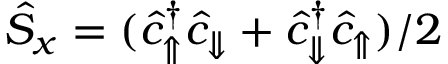Convert formula to latex. <formula><loc_0><loc_0><loc_500><loc_500>\hat { S } _ { x } = ( \hat { c } _ { \Uparrow } ^ { \dagger } \hat { c } _ { \Downarrow } + \hat { c } _ { \Downarrow } ^ { \dagger } \hat { c } _ { \Uparrow } ) / 2</formula> 